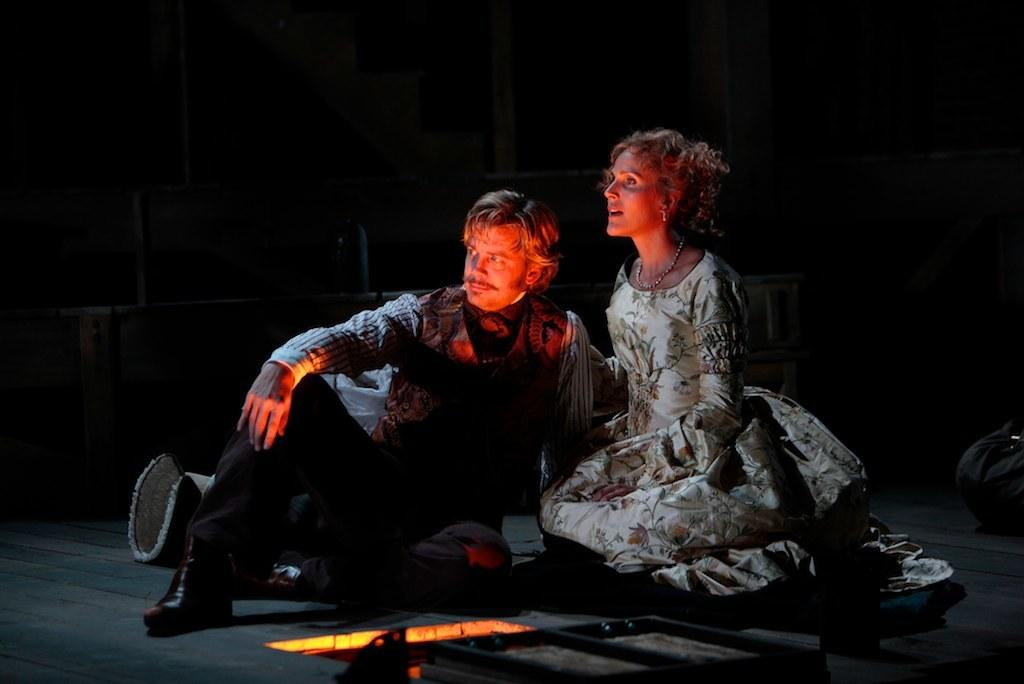How many people are in the image? There are two persons in the image. Can you describe the gender of the two people? One of the persons is a man, and the other person is a woman. What are the two people doing in the image? Both the man and the woman are sitting. What type of vessel can be seen in the image? There is no vessel present in the image. Can you describe the garden in the image? There is no garden present in the image. What type of tank is visible in the image? There is no tank present in the image. 